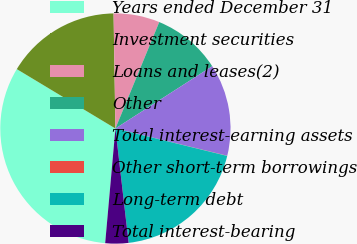<chart> <loc_0><loc_0><loc_500><loc_500><pie_chart><fcel>Years ended December 31<fcel>Investment securities<fcel>Loans and leases(2)<fcel>Other<fcel>Total interest-earning assets<fcel>Other short-term borrowings<fcel>Long-term debt<fcel>Total interest-bearing<nl><fcel>32.21%<fcel>16.12%<fcel>6.47%<fcel>9.68%<fcel>12.9%<fcel>0.03%<fcel>19.34%<fcel>3.25%<nl></chart> 